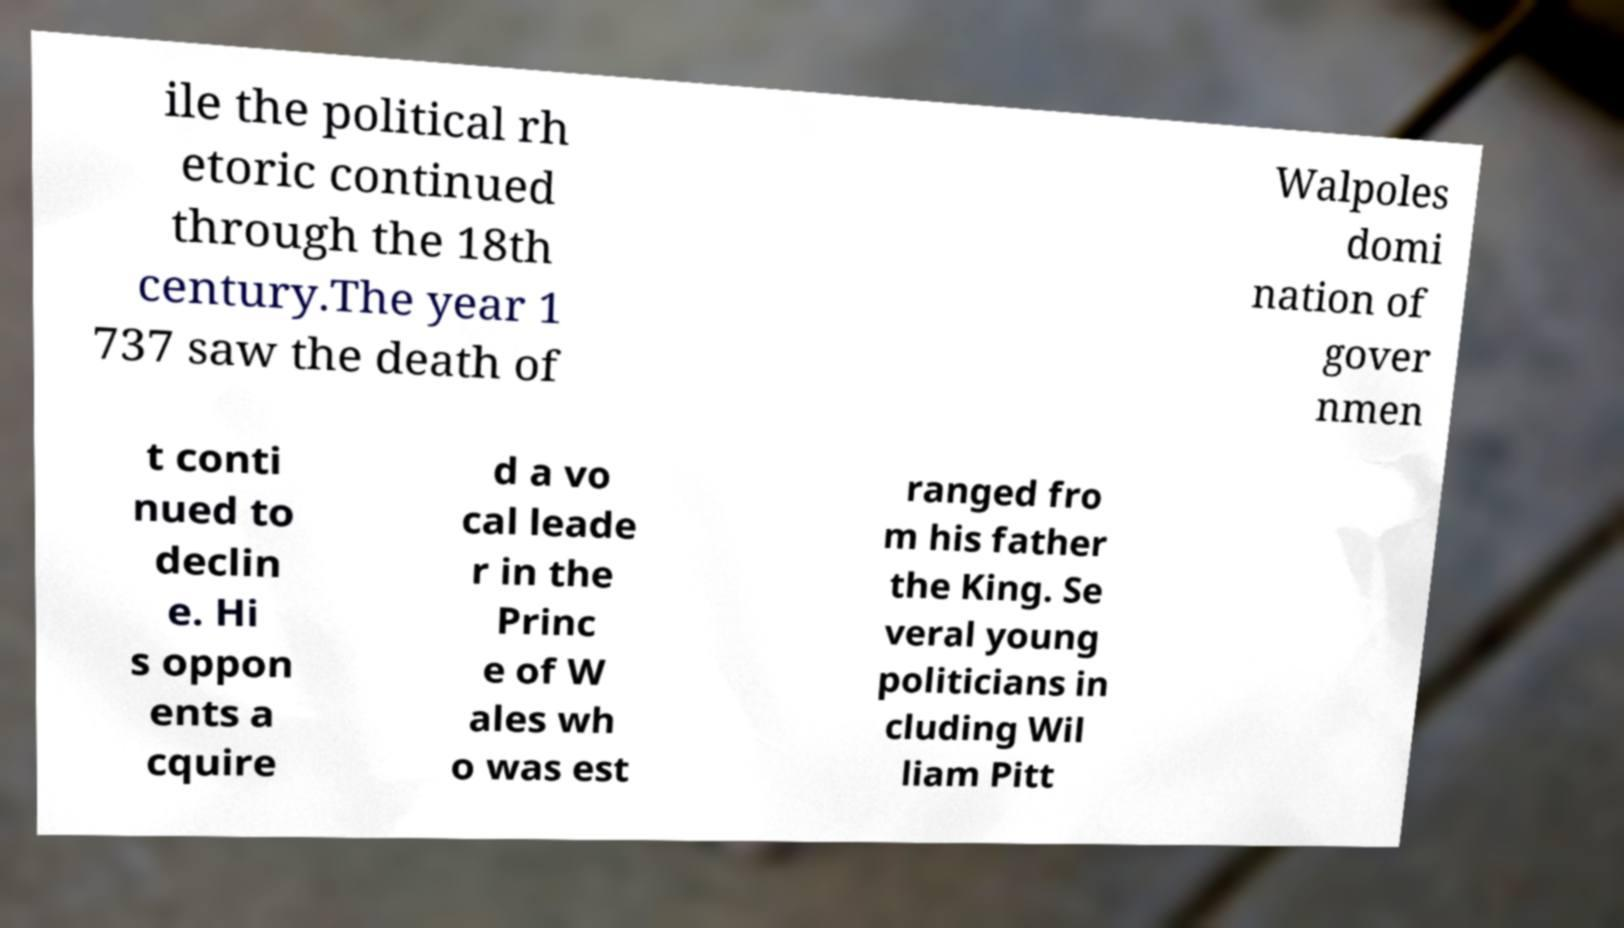Can you accurately transcribe the text from the provided image for me? ile the political rh etoric continued through the 18th century.The year 1 737 saw the death of Walpoles domi nation of gover nmen t conti nued to declin e. Hi s oppon ents a cquire d a vo cal leade r in the Princ e of W ales wh o was est ranged fro m his father the King. Se veral young politicians in cluding Wil liam Pitt 